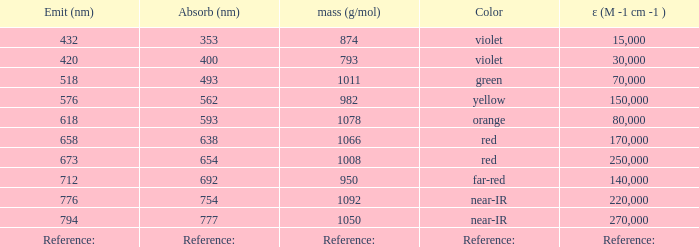Which ε (M -1 cm -1) has a molar mass of 1008 g/mol? 250000.0. 